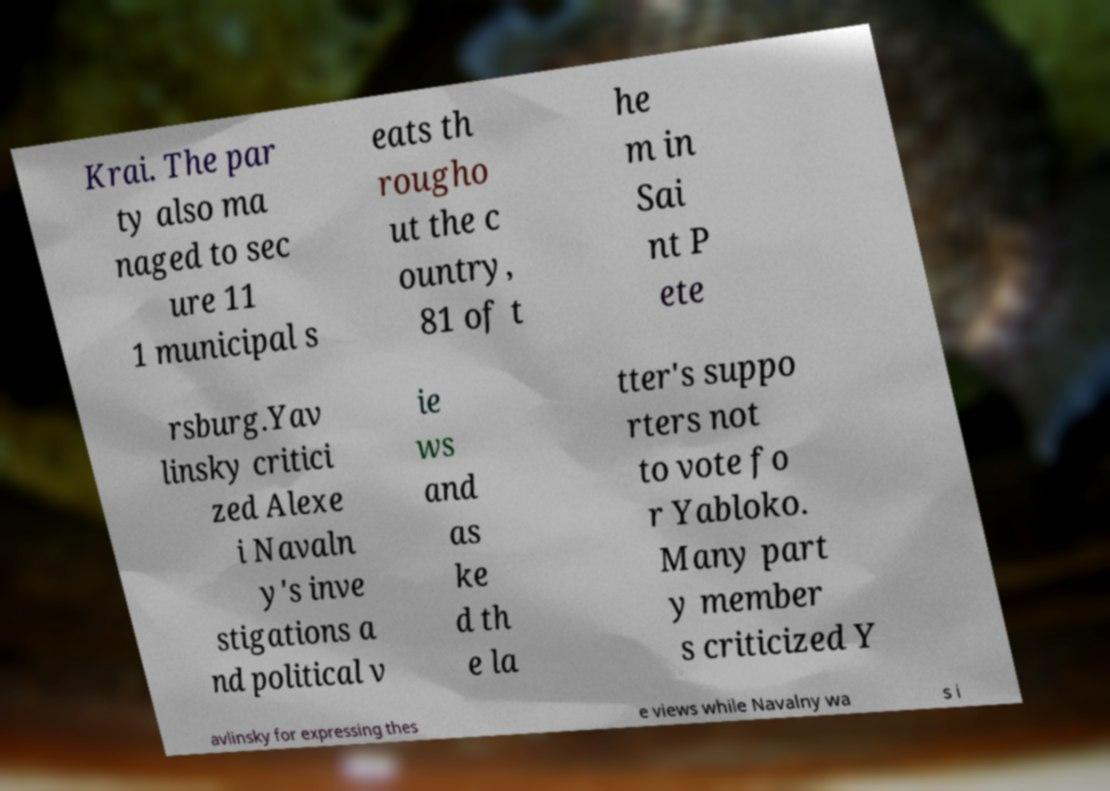I need the written content from this picture converted into text. Can you do that? Krai. The par ty also ma naged to sec ure 11 1 municipal s eats th rougho ut the c ountry, 81 of t he m in Sai nt P ete rsburg.Yav linsky critici zed Alexe i Navaln y's inve stigations a nd political v ie ws and as ke d th e la tter's suppo rters not to vote fo r Yabloko. Many part y member s criticized Y avlinsky for expressing thes e views while Navalny wa s i 